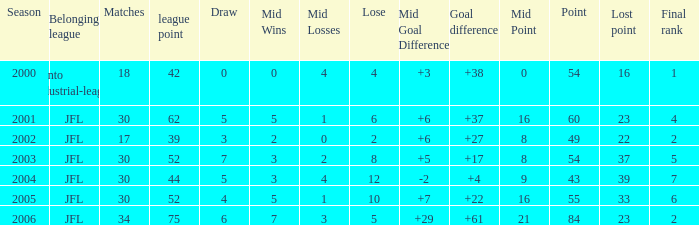Provide the peak matches for point 43 and ultimate position under None. 